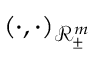Convert formula to latex. <formula><loc_0><loc_0><loc_500><loc_500>( \cdot , \cdot ) _ { \ m a t h s c r { R } _ { \pm } ^ { m } }</formula> 